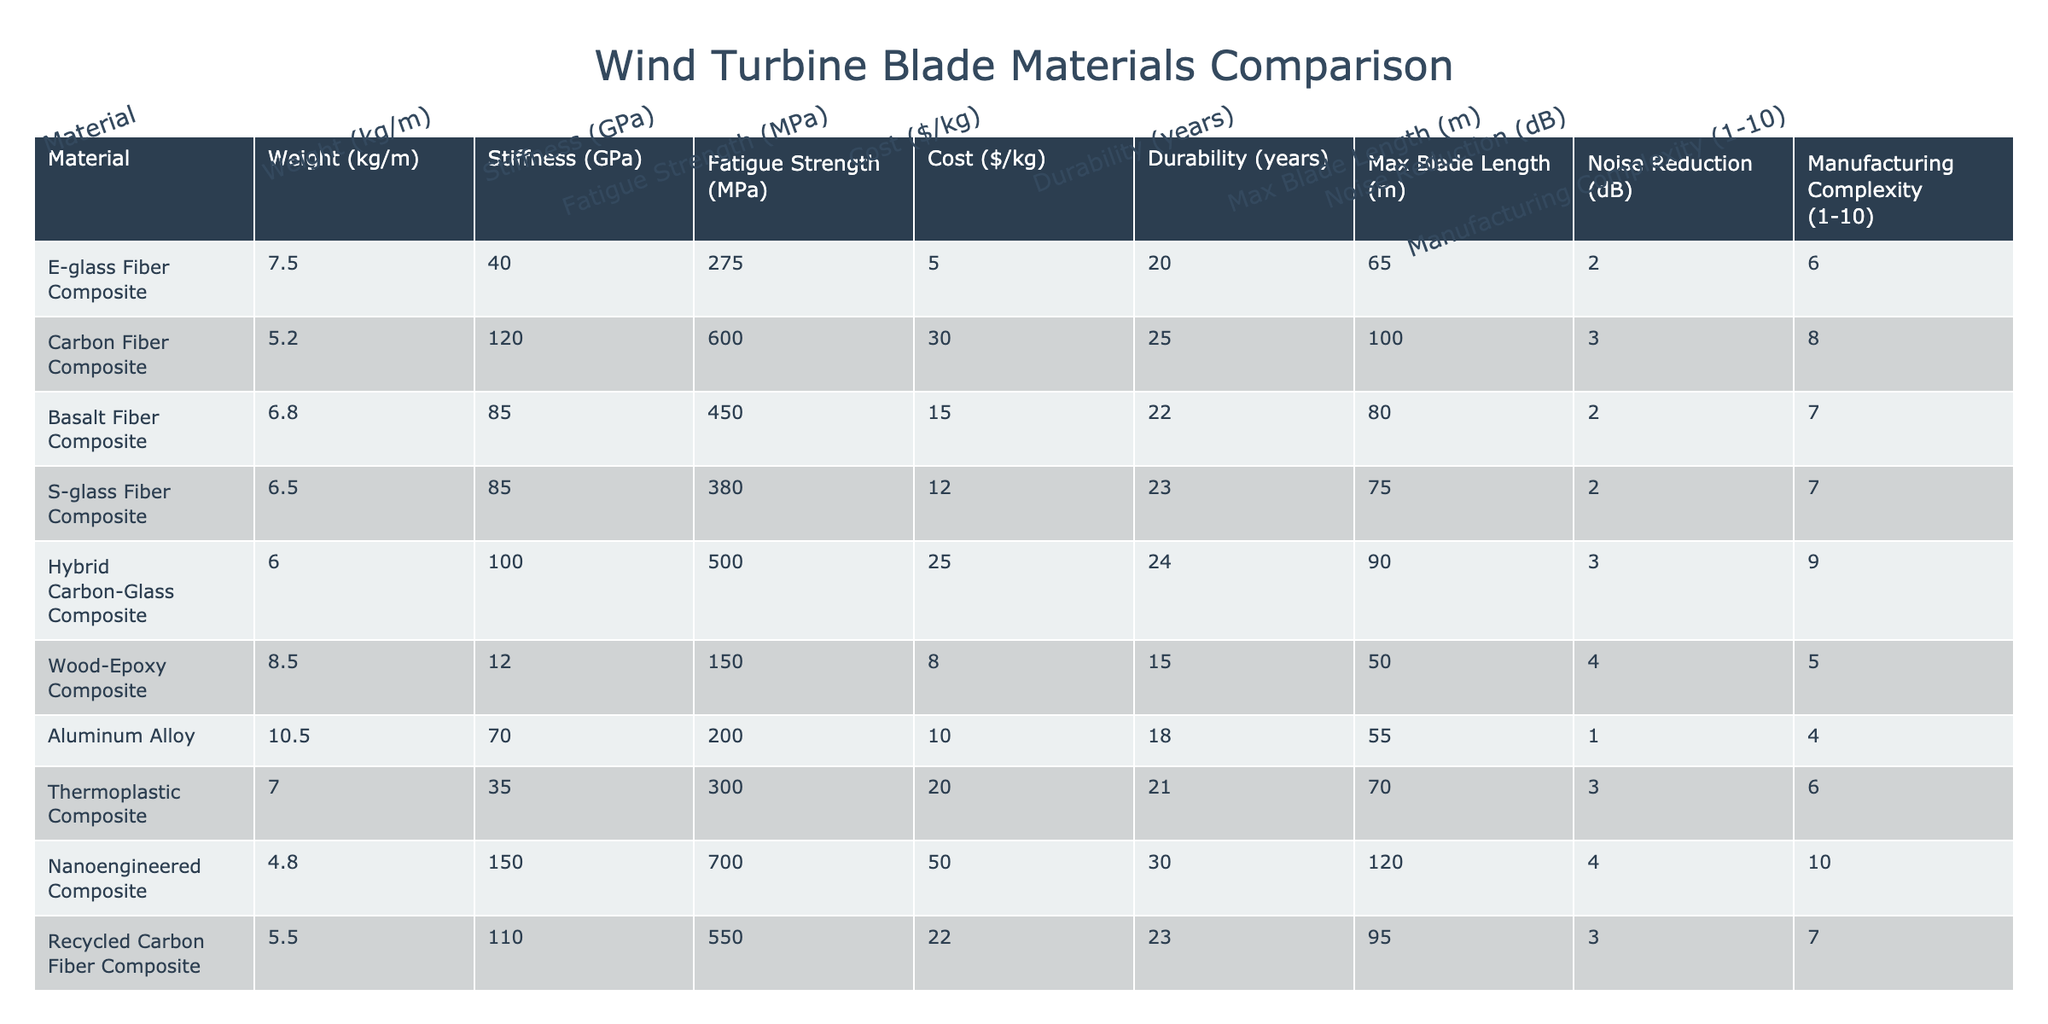What is the maximum blade length for the Carbon Fiber Composite? The table shows that the maximum blade length for Carbon Fiber Composite is listed as 100 m.
Answer: 100 m Which material has the highest fatigue strength? By comparing the fatigue strength values in the table, Carbon Fiber Composite has the highest value at 600 MPa.
Answer: 600 MPa How much more does the Nanoengineered Composite cost per kg compared to the Wood-Epoxy Composite? The cost of Nanoengineered Composite is $50/kg and the Wood-Epoxy Composite is $8/kg. Subtracting these values gives $50 - $8 = $42.
Answer: $42 What is the average durability of all composite materials listed? The durability values (in years) for the composite materials are 20, 25, 22, 23, 24, 15, 21, 30, and 23. Summing these values gives 20 + 25 + 22 + 23 + 24 + 15 + 21 + 30 + 23 = 213. There are 9 materials, so the average is 213 / 9 = 23.67, rounded to 24.
Answer: 24 Is the Aluminum Alloy the lightest material among the options? Comparing the weights in the table, Aluminum Alloy weighs 10.5 kg/m, which is heavier than the lightest option (Carbon Fiber Composite at 5.2 kg/m), making it false to say it is the lightest.
Answer: No Which materials have a noise reduction of 3 dB? Looking through the table, both Carbon Fiber Composite and Thermoplastic Composite are listed with a noise reduction of 3 dB.
Answer: Carbon Fiber Composite, Thermoplastic Composite What is the difference in maximum blade length between the E-glass Fiber Composite and the Basalt Fiber Composite? The maximum blade length for E-glass Fiber Composite is 65 m and for Basalt Fiber Composite is 80 m. The difference is 80 - 65 = 15 m.
Answer: 15 m Is the S-glass Fiber Composite more durable than the Wood-Epoxy Composite? The durability of S-glass Fiber Composite is 23 years and for Wood-Epoxy Composite it is 15 years, indicating that S-glass Fiber Composite is indeed more durable.
Answer: Yes Which material has the highest manufacturing complexity rating? The table shows that the Nanoengineered Composite has a manufacturing complexity rating of 10, which is the highest among all materials listed.
Answer: 10 